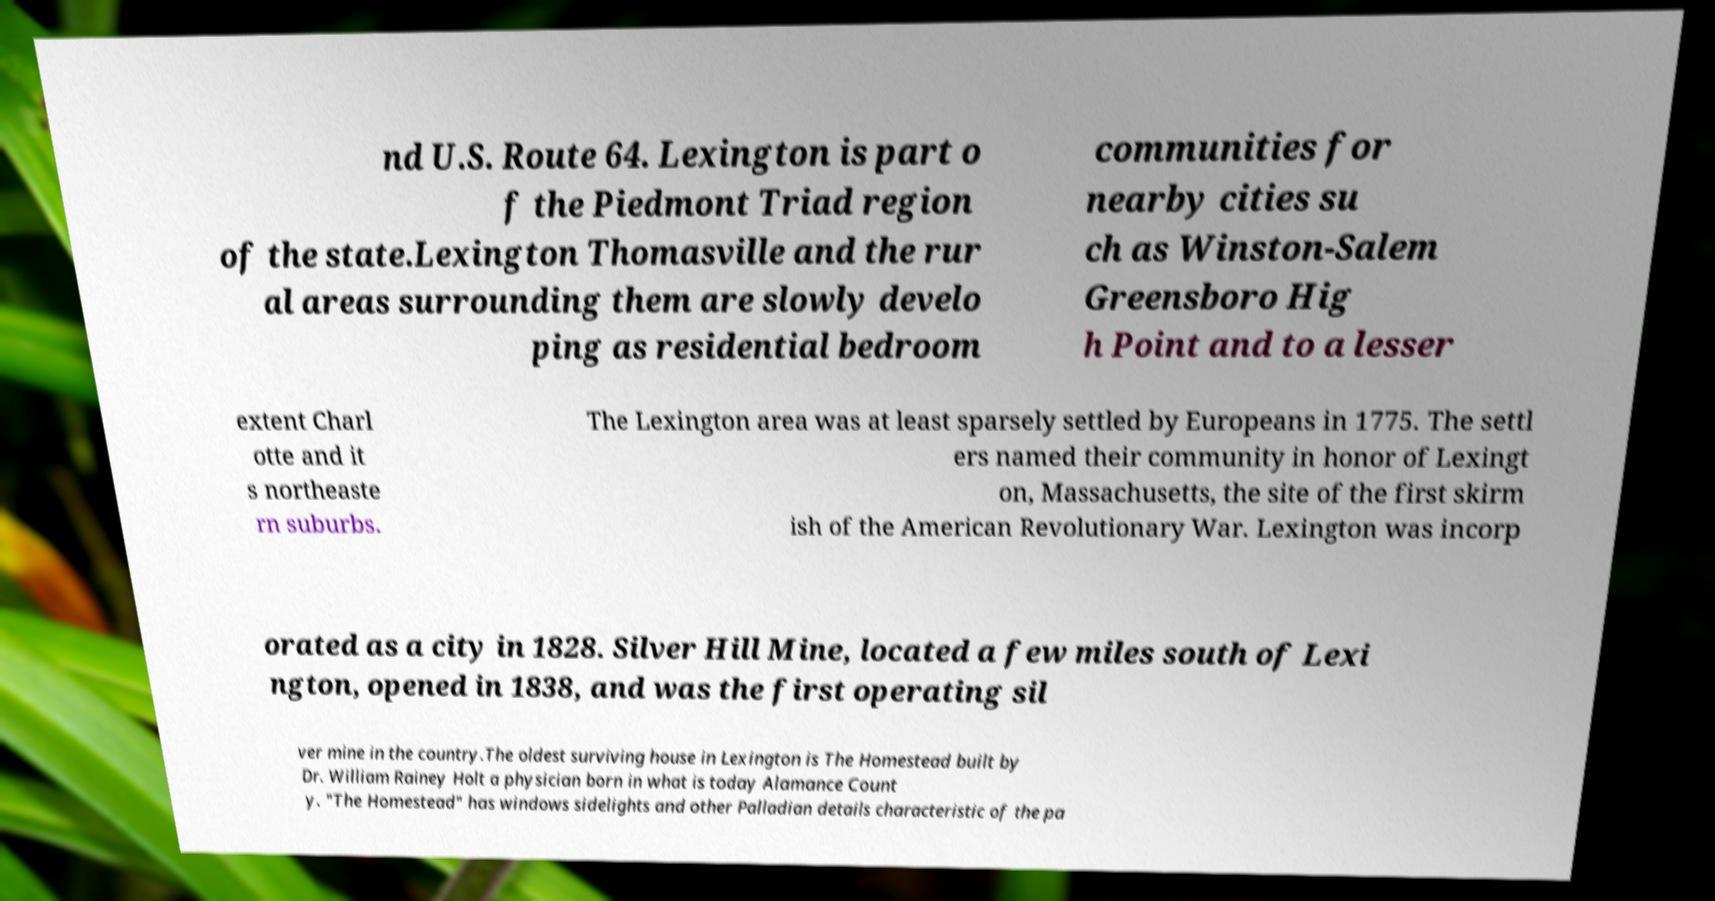Please read and relay the text visible in this image. What does it say? nd U.S. Route 64. Lexington is part o f the Piedmont Triad region of the state.Lexington Thomasville and the rur al areas surrounding them are slowly develo ping as residential bedroom communities for nearby cities su ch as Winston-Salem Greensboro Hig h Point and to a lesser extent Charl otte and it s northeaste rn suburbs. The Lexington area was at least sparsely settled by Europeans in 1775. The settl ers named their community in honor of Lexingt on, Massachusetts, the site of the first skirm ish of the American Revolutionary War. Lexington was incorp orated as a city in 1828. Silver Hill Mine, located a few miles south of Lexi ngton, opened in 1838, and was the first operating sil ver mine in the country.The oldest surviving house in Lexington is The Homestead built by Dr. William Rainey Holt a physician born in what is today Alamance Count y. "The Homestead" has windows sidelights and other Palladian details characteristic of the pa 